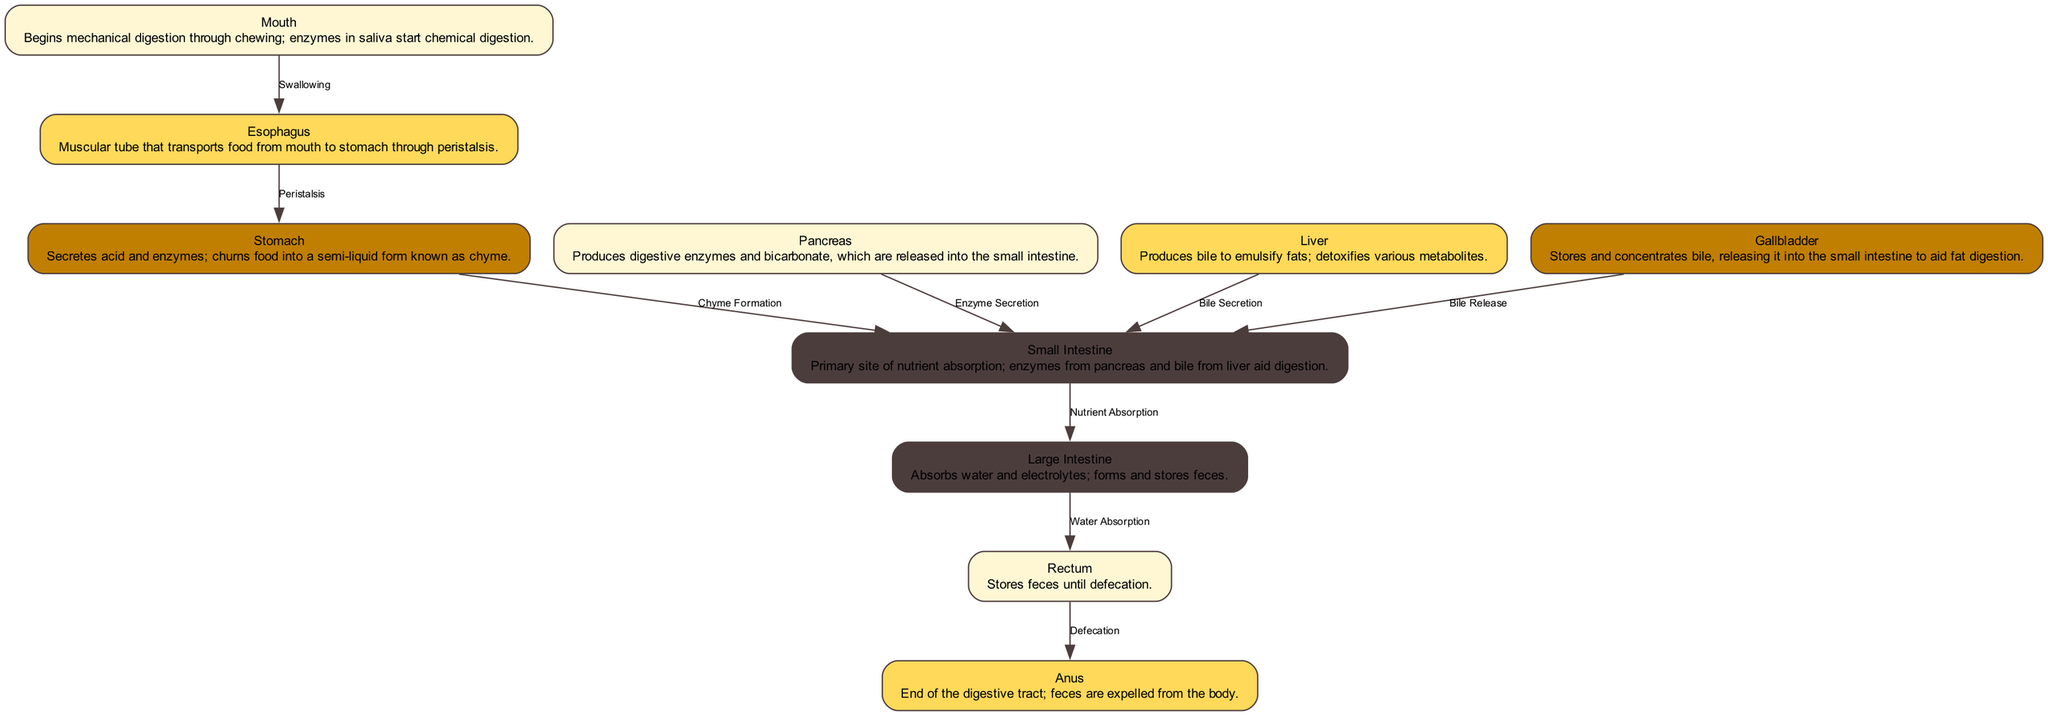What is the first part of the digestive system? The diagram indicates that the first part of the digestive system is the "Mouth," where digestion begins.
Answer: Mouth How does food move from the mouth to the stomach? The diagram shows that food is transported from the mouth to the stomach via "Swallowing," a process depicted by an edge.
Answer: Swallowing Which organ is responsible for producing bile? The diagram specifies that the "Liver" is responsible for producing bile, indicated in the description for the liver node.
Answer: Liver How many edges are present in the diagram? By counting the lines connecting the nodes, we observe that there are 9 edges illustrated in the diagram.
Answer: 9 What is absorbed in the large intestine? The diagram states that the large intestine absorbs "water and electrolytes," which is mentioned in the node's description.
Answer: Water and electrolytes What is the function of the pancreas in digestion? The diagram explains that the pancreas produces "digestive enzymes and bicarbonate," which highlights its role in aiding digestion in the small intestine.
Answer: Digestive enzymes and bicarbonate What connects the stomach to the small intestine? According to the diagram, the stomach connects to the small intestine through "Chyme Formation," denoting the process that changes food into chyme.
Answer: Chyme Formation What process occurs in the small intestine? The diagram illustrates that "Nutrient Absorption" occurs in the small intestine, as indicated by the edge connecting it to the large intestine.
Answer: Nutrient Absorption What happens in the rectum before defecation? The diagram indicates that the rectum stores feces prior to the process of defecation, as stated in the description of the rectum node.
Answer: Stores feces 